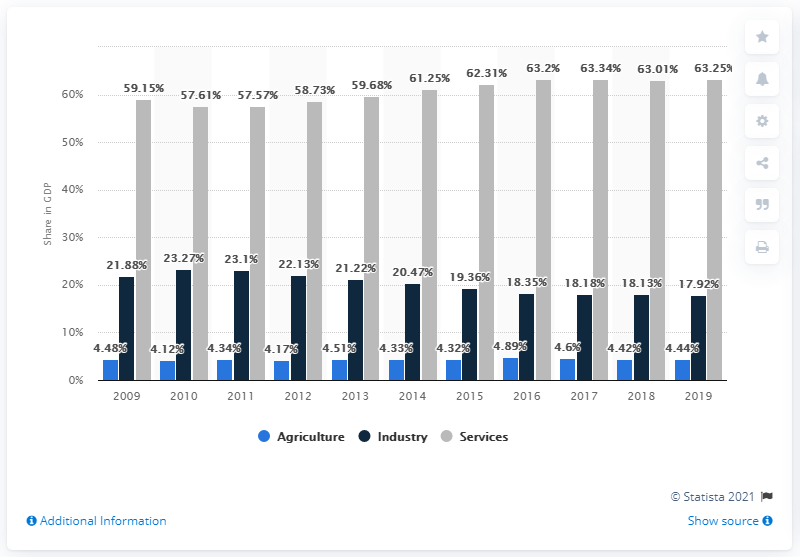Draw attention to some important aspects in this diagram. In 2021, the services sector contributed approximately 63.25% of Brazil's gross domestic product. 